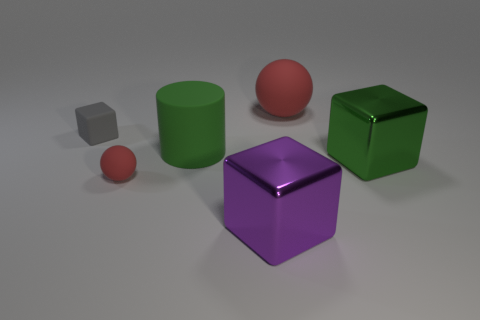Is the size of the rubber cylinder the same as the rubber block? The rubber cylinder appears to be slightly taller than the gray rubber block, but their diameters seem to be quite similar. Given that the term 'size' can refer to any aspect of an object's dimensions, the answer is somewhat subjective. If we're comparing heights, the cylinder is larger; if we're comparing volumes, it's difficult to determine without exact measurements. 